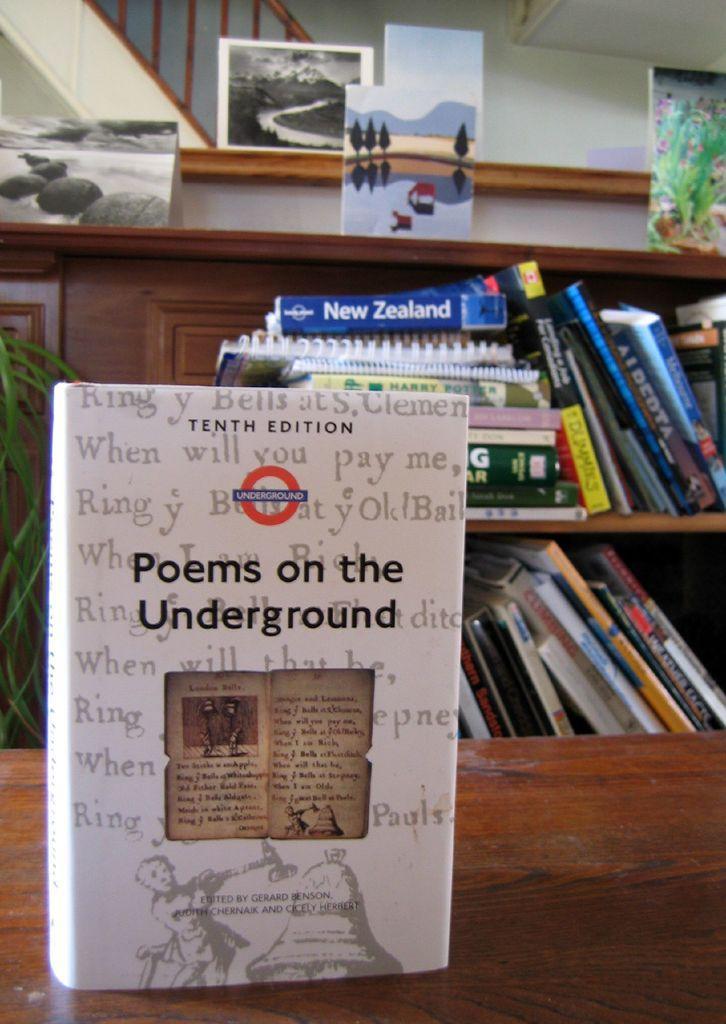Can you describe this image briefly? In this picture we can see a book in the front, at the bottom there is a wooden surface, we can see shelves in the background, there are some books present on these shelves, we can also see photo frames in the background. 